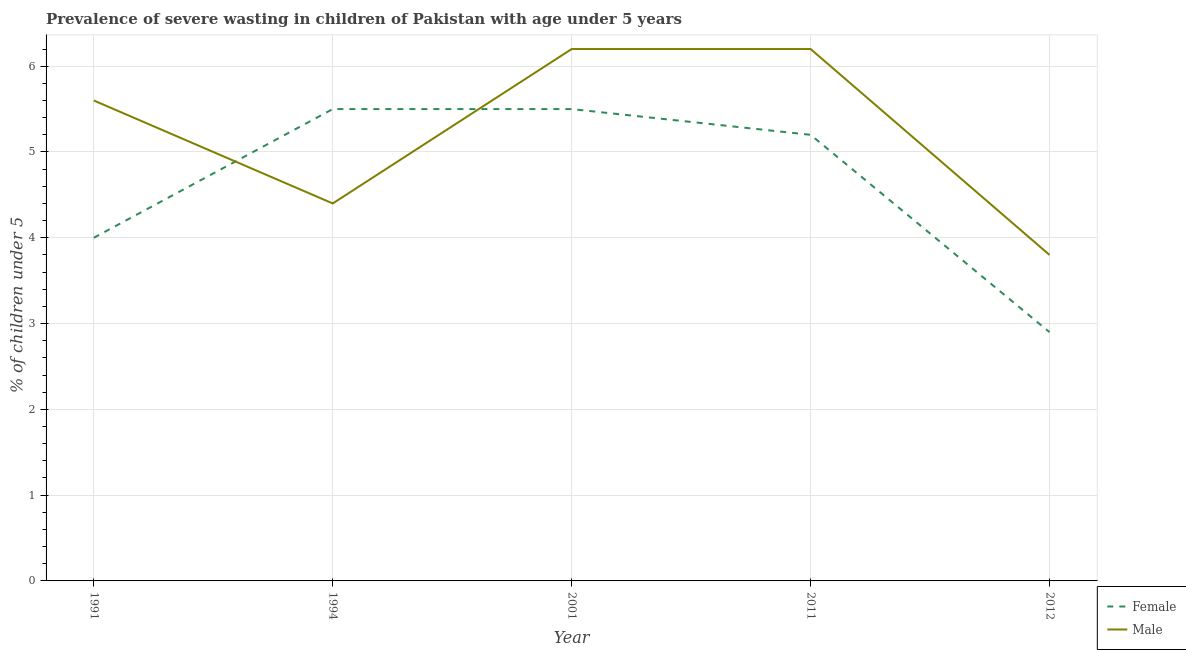How many different coloured lines are there?
Your response must be concise. 2. Is the number of lines equal to the number of legend labels?
Keep it short and to the point. Yes. Across all years, what is the maximum percentage of undernourished male children?
Your response must be concise. 6.2. Across all years, what is the minimum percentage of undernourished female children?
Offer a very short reply. 2.9. What is the total percentage of undernourished female children in the graph?
Your answer should be very brief. 23.1. What is the difference between the percentage of undernourished male children in 1991 and that in 2001?
Your response must be concise. -0.6. What is the average percentage of undernourished male children per year?
Give a very brief answer. 5.24. In the year 1991, what is the difference between the percentage of undernourished male children and percentage of undernourished female children?
Ensure brevity in your answer.  1.6. In how many years, is the percentage of undernourished female children greater than 2.2 %?
Keep it short and to the point. 5. What is the ratio of the percentage of undernourished female children in 2011 to that in 2012?
Offer a terse response. 1.79. Is the percentage of undernourished male children in 1994 less than that in 2011?
Provide a succinct answer. Yes. What is the difference between the highest and the second highest percentage of undernourished female children?
Offer a terse response. 0. What is the difference between the highest and the lowest percentage of undernourished male children?
Keep it short and to the point. 2.4. Is the percentage of undernourished female children strictly less than the percentage of undernourished male children over the years?
Your answer should be very brief. No. How many years are there in the graph?
Offer a very short reply. 5. Are the values on the major ticks of Y-axis written in scientific E-notation?
Offer a terse response. No. Does the graph contain grids?
Your response must be concise. Yes. How are the legend labels stacked?
Provide a succinct answer. Vertical. What is the title of the graph?
Your response must be concise. Prevalence of severe wasting in children of Pakistan with age under 5 years. What is the label or title of the X-axis?
Make the answer very short. Year. What is the label or title of the Y-axis?
Make the answer very short.  % of children under 5. What is the  % of children under 5 in Male in 1991?
Ensure brevity in your answer.  5.6. What is the  % of children under 5 of Male in 1994?
Offer a terse response. 4.4. What is the  % of children under 5 of Female in 2001?
Provide a short and direct response. 5.5. What is the  % of children under 5 in Male in 2001?
Provide a succinct answer. 6.2. What is the  % of children under 5 in Female in 2011?
Give a very brief answer. 5.2. What is the  % of children under 5 of Male in 2011?
Make the answer very short. 6.2. What is the  % of children under 5 of Female in 2012?
Ensure brevity in your answer.  2.9. What is the  % of children under 5 in Male in 2012?
Your response must be concise. 3.8. Across all years, what is the maximum  % of children under 5 of Female?
Provide a succinct answer. 5.5. Across all years, what is the maximum  % of children under 5 of Male?
Provide a short and direct response. 6.2. Across all years, what is the minimum  % of children under 5 in Female?
Your answer should be very brief. 2.9. Across all years, what is the minimum  % of children under 5 of Male?
Offer a very short reply. 3.8. What is the total  % of children under 5 of Female in the graph?
Provide a short and direct response. 23.1. What is the total  % of children under 5 in Male in the graph?
Keep it short and to the point. 26.2. What is the difference between the  % of children under 5 in Male in 1991 and that in 1994?
Give a very brief answer. 1.2. What is the difference between the  % of children under 5 of Male in 1991 and that in 2001?
Ensure brevity in your answer.  -0.6. What is the difference between the  % of children under 5 of Female in 1991 and that in 2012?
Your answer should be compact. 1.1. What is the difference between the  % of children under 5 in Female in 1994 and that in 2012?
Offer a terse response. 2.6. What is the difference between the  % of children under 5 in Male in 2001 and that in 2011?
Your answer should be very brief. 0. What is the difference between the  % of children under 5 in Female in 2001 and that in 2012?
Your response must be concise. 2.6. What is the difference between the  % of children under 5 in Male in 2001 and that in 2012?
Your response must be concise. 2.4. What is the difference between the  % of children under 5 in Female in 1991 and the  % of children under 5 in Male in 2001?
Your response must be concise. -2.2. What is the difference between the  % of children under 5 in Female in 1991 and the  % of children under 5 in Male in 2011?
Your response must be concise. -2.2. What is the difference between the  % of children under 5 of Female in 1994 and the  % of children under 5 of Male in 2012?
Ensure brevity in your answer.  1.7. What is the difference between the  % of children under 5 in Female in 2001 and the  % of children under 5 in Male in 2011?
Give a very brief answer. -0.7. What is the difference between the  % of children under 5 of Female in 2001 and the  % of children under 5 of Male in 2012?
Give a very brief answer. 1.7. What is the average  % of children under 5 of Female per year?
Your response must be concise. 4.62. What is the average  % of children under 5 in Male per year?
Offer a very short reply. 5.24. In the year 2001, what is the difference between the  % of children under 5 of Female and  % of children under 5 of Male?
Your answer should be compact. -0.7. In the year 2012, what is the difference between the  % of children under 5 of Female and  % of children under 5 of Male?
Your answer should be very brief. -0.9. What is the ratio of the  % of children under 5 of Female in 1991 to that in 1994?
Keep it short and to the point. 0.73. What is the ratio of the  % of children under 5 of Male in 1991 to that in 1994?
Provide a succinct answer. 1.27. What is the ratio of the  % of children under 5 in Female in 1991 to that in 2001?
Make the answer very short. 0.73. What is the ratio of the  % of children under 5 in Male in 1991 to that in 2001?
Make the answer very short. 0.9. What is the ratio of the  % of children under 5 of Female in 1991 to that in 2011?
Offer a very short reply. 0.77. What is the ratio of the  % of children under 5 in Male in 1991 to that in 2011?
Offer a very short reply. 0.9. What is the ratio of the  % of children under 5 in Female in 1991 to that in 2012?
Ensure brevity in your answer.  1.38. What is the ratio of the  % of children under 5 in Male in 1991 to that in 2012?
Make the answer very short. 1.47. What is the ratio of the  % of children under 5 in Male in 1994 to that in 2001?
Give a very brief answer. 0.71. What is the ratio of the  % of children under 5 of Female in 1994 to that in 2011?
Provide a short and direct response. 1.06. What is the ratio of the  % of children under 5 of Male in 1994 to that in 2011?
Your response must be concise. 0.71. What is the ratio of the  % of children under 5 of Female in 1994 to that in 2012?
Offer a terse response. 1.9. What is the ratio of the  % of children under 5 in Male in 1994 to that in 2012?
Give a very brief answer. 1.16. What is the ratio of the  % of children under 5 of Female in 2001 to that in 2011?
Provide a short and direct response. 1.06. What is the ratio of the  % of children under 5 in Female in 2001 to that in 2012?
Give a very brief answer. 1.9. What is the ratio of the  % of children under 5 in Male in 2001 to that in 2012?
Make the answer very short. 1.63. What is the ratio of the  % of children under 5 of Female in 2011 to that in 2012?
Offer a very short reply. 1.79. What is the ratio of the  % of children under 5 of Male in 2011 to that in 2012?
Provide a short and direct response. 1.63. What is the difference between the highest and the lowest  % of children under 5 in Female?
Provide a short and direct response. 2.6. What is the difference between the highest and the lowest  % of children under 5 in Male?
Make the answer very short. 2.4. 